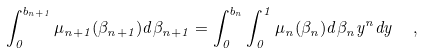Convert formula to latex. <formula><loc_0><loc_0><loc_500><loc_500>\int _ { 0 } ^ { b _ { n + 1 } } \mu _ { n + 1 } ( \beta _ { n + 1 } ) d \beta _ { n + 1 } = \int _ { 0 } ^ { b _ { n } } \int _ { 0 } ^ { 1 } { \mu _ { n } ( \beta _ { n } ) } d \beta _ { n } { y ^ { n } } d y \ \ ,</formula> 